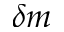<formula> <loc_0><loc_0><loc_500><loc_500>\delta m</formula> 